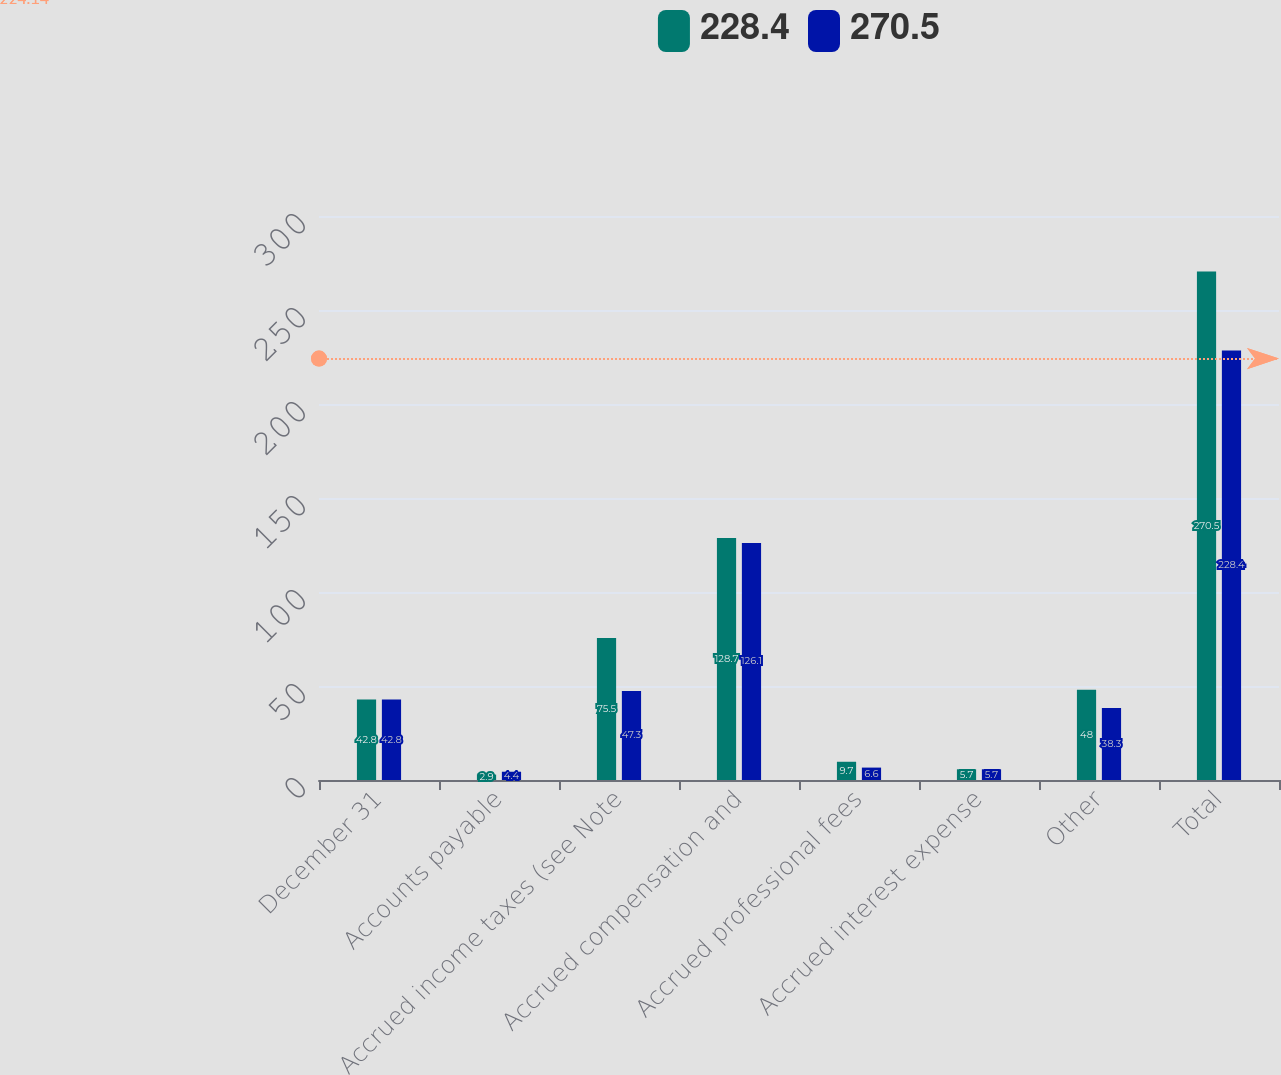<chart> <loc_0><loc_0><loc_500><loc_500><stacked_bar_chart><ecel><fcel>December 31<fcel>Accounts payable<fcel>Accrued income taxes (see Note<fcel>Accrued compensation and<fcel>Accrued professional fees<fcel>Accrued interest expense<fcel>Other<fcel>Total<nl><fcel>228.4<fcel>42.8<fcel>2.9<fcel>75.5<fcel>128.7<fcel>9.7<fcel>5.7<fcel>48<fcel>270.5<nl><fcel>270.5<fcel>42.8<fcel>4.4<fcel>47.3<fcel>126.1<fcel>6.6<fcel>5.7<fcel>38.3<fcel>228.4<nl></chart> 